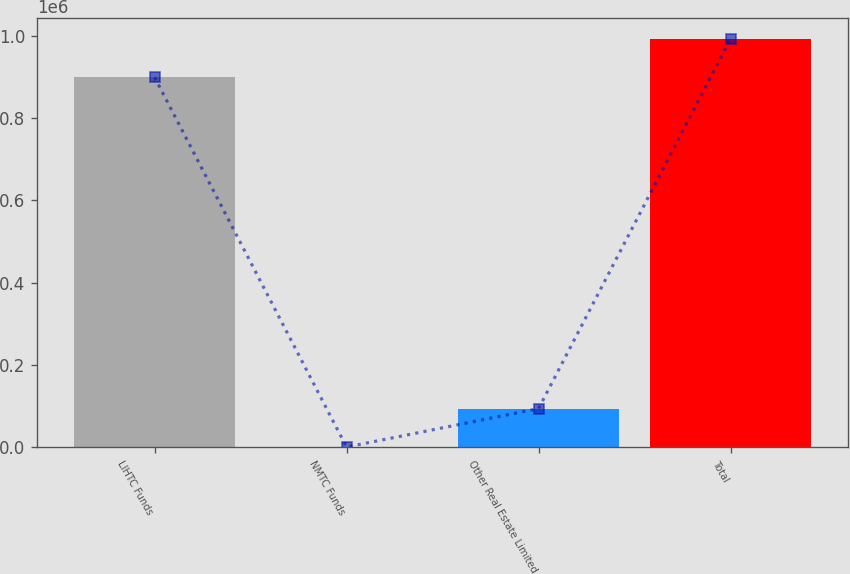<chart> <loc_0><loc_0><loc_500><loc_500><bar_chart><fcel>LIHTC Funds<fcel>NMTC Funds<fcel>Other Real Estate Limited<fcel>Total<nl><fcel>899586<fcel>2<fcel>93586.8<fcel>993171<nl></chart> 